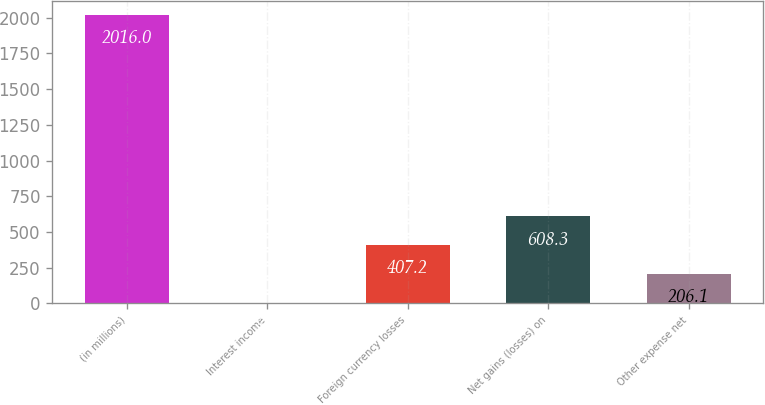<chart> <loc_0><loc_0><loc_500><loc_500><bar_chart><fcel>(in millions)<fcel>Interest income<fcel>Foreign currency losses<fcel>Net gains (losses) on<fcel>Other expense net<nl><fcel>2016<fcel>5<fcel>407.2<fcel>608.3<fcel>206.1<nl></chart> 